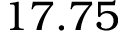Convert formula to latex. <formula><loc_0><loc_0><loc_500><loc_500>1 7 . 7 5</formula> 